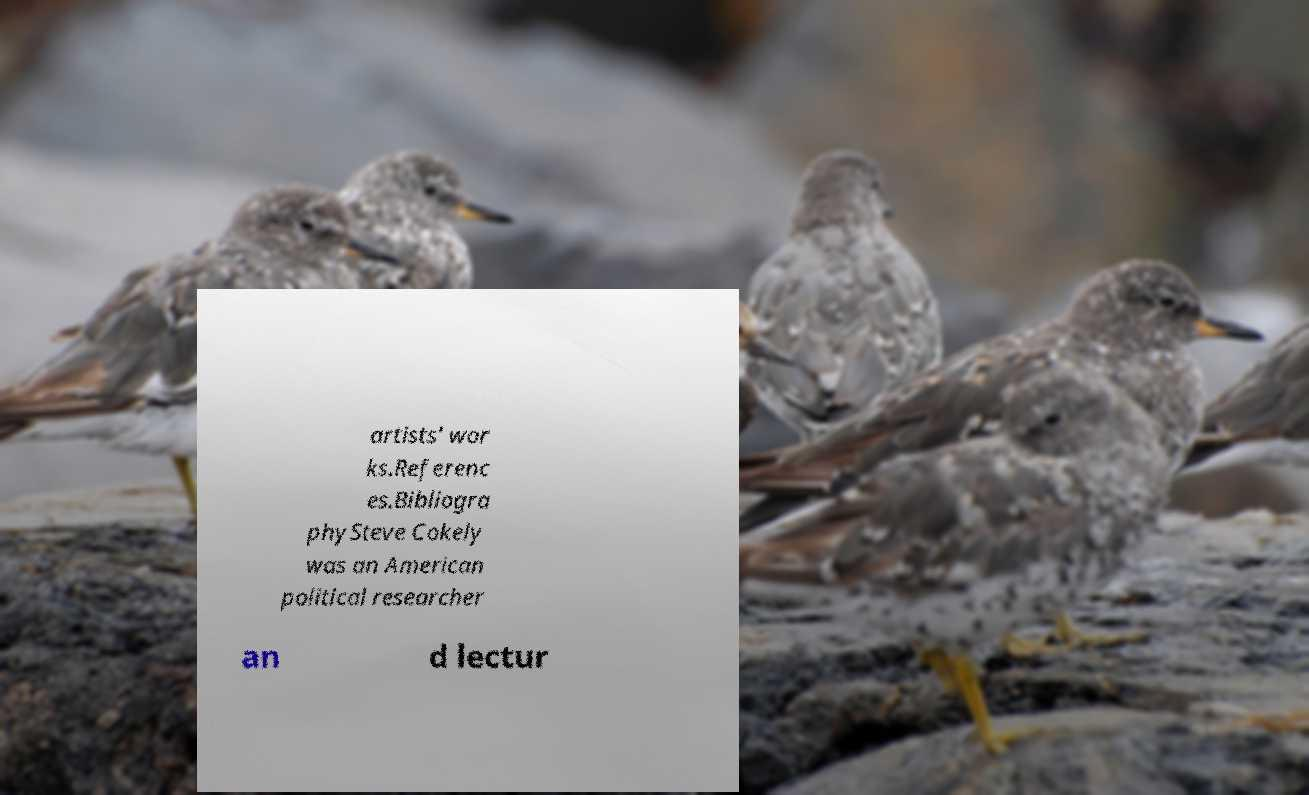Please identify and transcribe the text found in this image. artists' wor ks.Referenc es.Bibliogra phySteve Cokely was an American political researcher an d lectur 